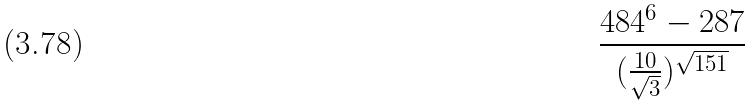Convert formula to latex. <formula><loc_0><loc_0><loc_500><loc_500>\frac { 4 8 4 ^ { 6 } - 2 8 7 } { ( \frac { 1 0 } { \sqrt { 3 } } ) ^ { \sqrt { 1 5 1 } } }</formula> 